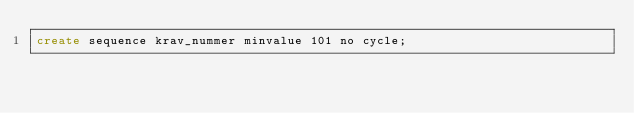Convert code to text. <code><loc_0><loc_0><loc_500><loc_500><_SQL_>create sequence krav_nummer minvalue 101 no cycle;</code> 